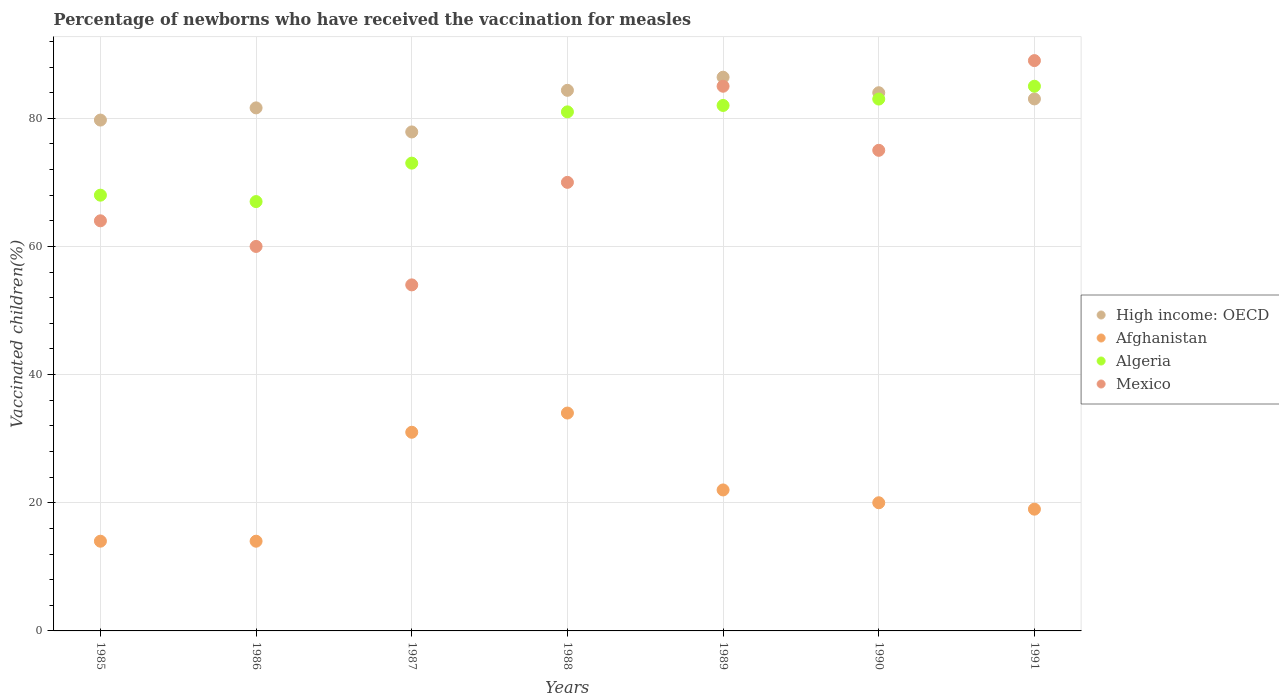How many different coloured dotlines are there?
Your response must be concise. 4. What is the percentage of vaccinated children in Afghanistan in 1986?
Provide a succinct answer. 14. Across all years, what is the maximum percentage of vaccinated children in Algeria?
Your answer should be compact. 85. Across all years, what is the minimum percentage of vaccinated children in Mexico?
Make the answer very short. 54. What is the total percentage of vaccinated children in Algeria in the graph?
Give a very brief answer. 539. What is the difference between the percentage of vaccinated children in Mexico in 1985 and the percentage of vaccinated children in High income: OECD in 1991?
Your answer should be compact. -19.02. What is the average percentage of vaccinated children in High income: OECD per year?
Keep it short and to the point. 82.43. In the year 1987, what is the difference between the percentage of vaccinated children in Algeria and percentage of vaccinated children in High income: OECD?
Provide a short and direct response. -4.87. What is the ratio of the percentage of vaccinated children in Algeria in 1986 to that in 1987?
Provide a short and direct response. 0.92. Is the difference between the percentage of vaccinated children in Algeria in 1985 and 1988 greater than the difference between the percentage of vaccinated children in High income: OECD in 1985 and 1988?
Offer a very short reply. No. What is the difference between the highest and the lowest percentage of vaccinated children in High income: OECD?
Make the answer very short. 8.54. Is the sum of the percentage of vaccinated children in Algeria in 1987 and 1990 greater than the maximum percentage of vaccinated children in Afghanistan across all years?
Your answer should be compact. Yes. Is it the case that in every year, the sum of the percentage of vaccinated children in Mexico and percentage of vaccinated children in Afghanistan  is greater than the sum of percentage of vaccinated children in Algeria and percentage of vaccinated children in High income: OECD?
Keep it short and to the point. No. Does the percentage of vaccinated children in Afghanistan monotonically increase over the years?
Give a very brief answer. No. Is the percentage of vaccinated children in Mexico strictly greater than the percentage of vaccinated children in Afghanistan over the years?
Your answer should be very brief. Yes. How many years are there in the graph?
Provide a succinct answer. 7. What is the difference between two consecutive major ticks on the Y-axis?
Give a very brief answer. 20. Are the values on the major ticks of Y-axis written in scientific E-notation?
Your response must be concise. No. Does the graph contain any zero values?
Ensure brevity in your answer.  No. Where does the legend appear in the graph?
Make the answer very short. Center right. What is the title of the graph?
Your response must be concise. Percentage of newborns who have received the vaccination for measles. What is the label or title of the X-axis?
Offer a very short reply. Years. What is the label or title of the Y-axis?
Make the answer very short. Vaccinated children(%). What is the Vaccinated children(%) in High income: OECD in 1985?
Offer a very short reply. 79.72. What is the Vaccinated children(%) in Algeria in 1985?
Give a very brief answer. 68. What is the Vaccinated children(%) in Mexico in 1985?
Your answer should be compact. 64. What is the Vaccinated children(%) of High income: OECD in 1986?
Provide a succinct answer. 81.62. What is the Vaccinated children(%) in Mexico in 1986?
Offer a terse response. 60. What is the Vaccinated children(%) of High income: OECD in 1987?
Offer a terse response. 77.87. What is the Vaccinated children(%) in High income: OECD in 1988?
Ensure brevity in your answer.  84.36. What is the Vaccinated children(%) of Afghanistan in 1988?
Your answer should be very brief. 34. What is the Vaccinated children(%) of High income: OECD in 1989?
Offer a very short reply. 86.41. What is the Vaccinated children(%) in High income: OECD in 1990?
Your response must be concise. 83.99. What is the Vaccinated children(%) of Algeria in 1990?
Provide a short and direct response. 83. What is the Vaccinated children(%) in Mexico in 1990?
Your answer should be compact. 75. What is the Vaccinated children(%) of High income: OECD in 1991?
Offer a very short reply. 83.02. What is the Vaccinated children(%) in Afghanistan in 1991?
Provide a succinct answer. 19. What is the Vaccinated children(%) in Algeria in 1991?
Provide a succinct answer. 85. What is the Vaccinated children(%) in Mexico in 1991?
Your answer should be very brief. 89. Across all years, what is the maximum Vaccinated children(%) in High income: OECD?
Make the answer very short. 86.41. Across all years, what is the maximum Vaccinated children(%) of Mexico?
Your answer should be very brief. 89. Across all years, what is the minimum Vaccinated children(%) in High income: OECD?
Give a very brief answer. 77.87. Across all years, what is the minimum Vaccinated children(%) in Afghanistan?
Your answer should be very brief. 14. What is the total Vaccinated children(%) in High income: OECD in the graph?
Make the answer very short. 576.99. What is the total Vaccinated children(%) of Afghanistan in the graph?
Give a very brief answer. 154. What is the total Vaccinated children(%) of Algeria in the graph?
Keep it short and to the point. 539. What is the total Vaccinated children(%) in Mexico in the graph?
Provide a succinct answer. 497. What is the difference between the Vaccinated children(%) of High income: OECD in 1985 and that in 1986?
Offer a very short reply. -1.9. What is the difference between the Vaccinated children(%) in Algeria in 1985 and that in 1986?
Offer a very short reply. 1. What is the difference between the Vaccinated children(%) in High income: OECD in 1985 and that in 1987?
Your response must be concise. 1.85. What is the difference between the Vaccinated children(%) in Mexico in 1985 and that in 1987?
Offer a very short reply. 10. What is the difference between the Vaccinated children(%) of High income: OECD in 1985 and that in 1988?
Your response must be concise. -4.64. What is the difference between the Vaccinated children(%) of Afghanistan in 1985 and that in 1988?
Your answer should be compact. -20. What is the difference between the Vaccinated children(%) in Algeria in 1985 and that in 1988?
Your answer should be very brief. -13. What is the difference between the Vaccinated children(%) of High income: OECD in 1985 and that in 1989?
Your answer should be compact. -6.69. What is the difference between the Vaccinated children(%) in Afghanistan in 1985 and that in 1989?
Your response must be concise. -8. What is the difference between the Vaccinated children(%) of Algeria in 1985 and that in 1989?
Your response must be concise. -14. What is the difference between the Vaccinated children(%) in Mexico in 1985 and that in 1989?
Your answer should be compact. -21. What is the difference between the Vaccinated children(%) of High income: OECD in 1985 and that in 1990?
Offer a terse response. -4.27. What is the difference between the Vaccinated children(%) in Afghanistan in 1985 and that in 1990?
Keep it short and to the point. -6. What is the difference between the Vaccinated children(%) of Algeria in 1985 and that in 1990?
Your answer should be very brief. -15. What is the difference between the Vaccinated children(%) of High income: OECD in 1985 and that in 1991?
Offer a terse response. -3.3. What is the difference between the Vaccinated children(%) of Afghanistan in 1985 and that in 1991?
Your answer should be compact. -5. What is the difference between the Vaccinated children(%) in High income: OECD in 1986 and that in 1987?
Ensure brevity in your answer.  3.75. What is the difference between the Vaccinated children(%) of Afghanistan in 1986 and that in 1987?
Provide a succinct answer. -17. What is the difference between the Vaccinated children(%) in Algeria in 1986 and that in 1987?
Your answer should be very brief. -6. What is the difference between the Vaccinated children(%) in Mexico in 1986 and that in 1987?
Provide a succinct answer. 6. What is the difference between the Vaccinated children(%) of High income: OECD in 1986 and that in 1988?
Ensure brevity in your answer.  -2.74. What is the difference between the Vaccinated children(%) in Afghanistan in 1986 and that in 1988?
Offer a terse response. -20. What is the difference between the Vaccinated children(%) of Mexico in 1986 and that in 1988?
Give a very brief answer. -10. What is the difference between the Vaccinated children(%) of High income: OECD in 1986 and that in 1989?
Keep it short and to the point. -4.79. What is the difference between the Vaccinated children(%) in Algeria in 1986 and that in 1989?
Keep it short and to the point. -15. What is the difference between the Vaccinated children(%) in High income: OECD in 1986 and that in 1990?
Offer a terse response. -2.36. What is the difference between the Vaccinated children(%) of Algeria in 1986 and that in 1990?
Ensure brevity in your answer.  -16. What is the difference between the Vaccinated children(%) in High income: OECD in 1986 and that in 1991?
Offer a terse response. -1.4. What is the difference between the Vaccinated children(%) of Algeria in 1986 and that in 1991?
Provide a short and direct response. -18. What is the difference between the Vaccinated children(%) of High income: OECD in 1987 and that in 1988?
Offer a terse response. -6.49. What is the difference between the Vaccinated children(%) in Mexico in 1987 and that in 1988?
Give a very brief answer. -16. What is the difference between the Vaccinated children(%) in High income: OECD in 1987 and that in 1989?
Offer a very short reply. -8.54. What is the difference between the Vaccinated children(%) of Afghanistan in 1987 and that in 1989?
Your response must be concise. 9. What is the difference between the Vaccinated children(%) in Algeria in 1987 and that in 1989?
Provide a succinct answer. -9. What is the difference between the Vaccinated children(%) of Mexico in 1987 and that in 1989?
Your response must be concise. -31. What is the difference between the Vaccinated children(%) of High income: OECD in 1987 and that in 1990?
Keep it short and to the point. -6.12. What is the difference between the Vaccinated children(%) of Algeria in 1987 and that in 1990?
Make the answer very short. -10. What is the difference between the Vaccinated children(%) of Mexico in 1987 and that in 1990?
Offer a terse response. -21. What is the difference between the Vaccinated children(%) of High income: OECD in 1987 and that in 1991?
Your response must be concise. -5.15. What is the difference between the Vaccinated children(%) of Afghanistan in 1987 and that in 1991?
Offer a very short reply. 12. What is the difference between the Vaccinated children(%) of Mexico in 1987 and that in 1991?
Your answer should be very brief. -35. What is the difference between the Vaccinated children(%) of High income: OECD in 1988 and that in 1989?
Ensure brevity in your answer.  -2.04. What is the difference between the Vaccinated children(%) of Afghanistan in 1988 and that in 1989?
Provide a short and direct response. 12. What is the difference between the Vaccinated children(%) of High income: OECD in 1988 and that in 1990?
Provide a short and direct response. 0.38. What is the difference between the Vaccinated children(%) of Algeria in 1988 and that in 1990?
Keep it short and to the point. -2. What is the difference between the Vaccinated children(%) of High income: OECD in 1988 and that in 1991?
Offer a very short reply. 1.34. What is the difference between the Vaccinated children(%) in Mexico in 1988 and that in 1991?
Offer a very short reply. -19. What is the difference between the Vaccinated children(%) in High income: OECD in 1989 and that in 1990?
Make the answer very short. 2.42. What is the difference between the Vaccinated children(%) of Algeria in 1989 and that in 1990?
Offer a terse response. -1. What is the difference between the Vaccinated children(%) of High income: OECD in 1989 and that in 1991?
Your answer should be compact. 3.39. What is the difference between the Vaccinated children(%) of Afghanistan in 1989 and that in 1991?
Ensure brevity in your answer.  3. What is the difference between the Vaccinated children(%) in Algeria in 1989 and that in 1991?
Offer a very short reply. -3. What is the difference between the Vaccinated children(%) of Mexico in 1989 and that in 1991?
Ensure brevity in your answer.  -4. What is the difference between the Vaccinated children(%) of High income: OECD in 1990 and that in 1991?
Your answer should be compact. 0.97. What is the difference between the Vaccinated children(%) of Algeria in 1990 and that in 1991?
Your answer should be very brief. -2. What is the difference between the Vaccinated children(%) in Mexico in 1990 and that in 1991?
Keep it short and to the point. -14. What is the difference between the Vaccinated children(%) in High income: OECD in 1985 and the Vaccinated children(%) in Afghanistan in 1986?
Your response must be concise. 65.72. What is the difference between the Vaccinated children(%) of High income: OECD in 1985 and the Vaccinated children(%) of Algeria in 1986?
Offer a very short reply. 12.72. What is the difference between the Vaccinated children(%) in High income: OECD in 1985 and the Vaccinated children(%) in Mexico in 1986?
Provide a succinct answer. 19.72. What is the difference between the Vaccinated children(%) of Afghanistan in 1985 and the Vaccinated children(%) of Algeria in 1986?
Keep it short and to the point. -53. What is the difference between the Vaccinated children(%) of Afghanistan in 1985 and the Vaccinated children(%) of Mexico in 1986?
Give a very brief answer. -46. What is the difference between the Vaccinated children(%) of Algeria in 1985 and the Vaccinated children(%) of Mexico in 1986?
Ensure brevity in your answer.  8. What is the difference between the Vaccinated children(%) of High income: OECD in 1985 and the Vaccinated children(%) of Afghanistan in 1987?
Your answer should be compact. 48.72. What is the difference between the Vaccinated children(%) of High income: OECD in 1985 and the Vaccinated children(%) of Algeria in 1987?
Provide a short and direct response. 6.72. What is the difference between the Vaccinated children(%) of High income: OECD in 1985 and the Vaccinated children(%) of Mexico in 1987?
Offer a very short reply. 25.72. What is the difference between the Vaccinated children(%) of Afghanistan in 1985 and the Vaccinated children(%) of Algeria in 1987?
Offer a very short reply. -59. What is the difference between the Vaccinated children(%) in Algeria in 1985 and the Vaccinated children(%) in Mexico in 1987?
Provide a short and direct response. 14. What is the difference between the Vaccinated children(%) in High income: OECD in 1985 and the Vaccinated children(%) in Afghanistan in 1988?
Your response must be concise. 45.72. What is the difference between the Vaccinated children(%) in High income: OECD in 1985 and the Vaccinated children(%) in Algeria in 1988?
Ensure brevity in your answer.  -1.28. What is the difference between the Vaccinated children(%) in High income: OECD in 1985 and the Vaccinated children(%) in Mexico in 1988?
Your response must be concise. 9.72. What is the difference between the Vaccinated children(%) of Afghanistan in 1985 and the Vaccinated children(%) of Algeria in 1988?
Your response must be concise. -67. What is the difference between the Vaccinated children(%) in Afghanistan in 1985 and the Vaccinated children(%) in Mexico in 1988?
Your answer should be very brief. -56. What is the difference between the Vaccinated children(%) in Algeria in 1985 and the Vaccinated children(%) in Mexico in 1988?
Your answer should be very brief. -2. What is the difference between the Vaccinated children(%) in High income: OECD in 1985 and the Vaccinated children(%) in Afghanistan in 1989?
Provide a succinct answer. 57.72. What is the difference between the Vaccinated children(%) of High income: OECD in 1985 and the Vaccinated children(%) of Algeria in 1989?
Offer a terse response. -2.28. What is the difference between the Vaccinated children(%) in High income: OECD in 1985 and the Vaccinated children(%) in Mexico in 1989?
Offer a very short reply. -5.28. What is the difference between the Vaccinated children(%) in Afghanistan in 1985 and the Vaccinated children(%) in Algeria in 1989?
Your response must be concise. -68. What is the difference between the Vaccinated children(%) of Afghanistan in 1985 and the Vaccinated children(%) of Mexico in 1989?
Keep it short and to the point. -71. What is the difference between the Vaccinated children(%) of High income: OECD in 1985 and the Vaccinated children(%) of Afghanistan in 1990?
Your answer should be compact. 59.72. What is the difference between the Vaccinated children(%) in High income: OECD in 1985 and the Vaccinated children(%) in Algeria in 1990?
Offer a terse response. -3.28. What is the difference between the Vaccinated children(%) in High income: OECD in 1985 and the Vaccinated children(%) in Mexico in 1990?
Keep it short and to the point. 4.72. What is the difference between the Vaccinated children(%) of Afghanistan in 1985 and the Vaccinated children(%) of Algeria in 1990?
Ensure brevity in your answer.  -69. What is the difference between the Vaccinated children(%) in Afghanistan in 1985 and the Vaccinated children(%) in Mexico in 1990?
Offer a very short reply. -61. What is the difference between the Vaccinated children(%) in High income: OECD in 1985 and the Vaccinated children(%) in Afghanistan in 1991?
Ensure brevity in your answer.  60.72. What is the difference between the Vaccinated children(%) in High income: OECD in 1985 and the Vaccinated children(%) in Algeria in 1991?
Keep it short and to the point. -5.28. What is the difference between the Vaccinated children(%) of High income: OECD in 1985 and the Vaccinated children(%) of Mexico in 1991?
Provide a short and direct response. -9.28. What is the difference between the Vaccinated children(%) in Afghanistan in 1985 and the Vaccinated children(%) in Algeria in 1991?
Make the answer very short. -71. What is the difference between the Vaccinated children(%) of Afghanistan in 1985 and the Vaccinated children(%) of Mexico in 1991?
Provide a succinct answer. -75. What is the difference between the Vaccinated children(%) in High income: OECD in 1986 and the Vaccinated children(%) in Afghanistan in 1987?
Offer a very short reply. 50.62. What is the difference between the Vaccinated children(%) of High income: OECD in 1986 and the Vaccinated children(%) of Algeria in 1987?
Provide a succinct answer. 8.62. What is the difference between the Vaccinated children(%) in High income: OECD in 1986 and the Vaccinated children(%) in Mexico in 1987?
Offer a very short reply. 27.62. What is the difference between the Vaccinated children(%) in Afghanistan in 1986 and the Vaccinated children(%) in Algeria in 1987?
Give a very brief answer. -59. What is the difference between the Vaccinated children(%) of High income: OECD in 1986 and the Vaccinated children(%) of Afghanistan in 1988?
Your answer should be compact. 47.62. What is the difference between the Vaccinated children(%) in High income: OECD in 1986 and the Vaccinated children(%) in Algeria in 1988?
Provide a short and direct response. 0.62. What is the difference between the Vaccinated children(%) in High income: OECD in 1986 and the Vaccinated children(%) in Mexico in 1988?
Keep it short and to the point. 11.62. What is the difference between the Vaccinated children(%) of Afghanistan in 1986 and the Vaccinated children(%) of Algeria in 1988?
Give a very brief answer. -67. What is the difference between the Vaccinated children(%) in Afghanistan in 1986 and the Vaccinated children(%) in Mexico in 1988?
Your response must be concise. -56. What is the difference between the Vaccinated children(%) in High income: OECD in 1986 and the Vaccinated children(%) in Afghanistan in 1989?
Provide a succinct answer. 59.62. What is the difference between the Vaccinated children(%) in High income: OECD in 1986 and the Vaccinated children(%) in Algeria in 1989?
Your response must be concise. -0.38. What is the difference between the Vaccinated children(%) of High income: OECD in 1986 and the Vaccinated children(%) of Mexico in 1989?
Your answer should be compact. -3.38. What is the difference between the Vaccinated children(%) of Afghanistan in 1986 and the Vaccinated children(%) of Algeria in 1989?
Give a very brief answer. -68. What is the difference between the Vaccinated children(%) of Afghanistan in 1986 and the Vaccinated children(%) of Mexico in 1989?
Keep it short and to the point. -71. What is the difference between the Vaccinated children(%) in Algeria in 1986 and the Vaccinated children(%) in Mexico in 1989?
Keep it short and to the point. -18. What is the difference between the Vaccinated children(%) of High income: OECD in 1986 and the Vaccinated children(%) of Afghanistan in 1990?
Ensure brevity in your answer.  61.62. What is the difference between the Vaccinated children(%) of High income: OECD in 1986 and the Vaccinated children(%) of Algeria in 1990?
Your answer should be compact. -1.38. What is the difference between the Vaccinated children(%) in High income: OECD in 1986 and the Vaccinated children(%) in Mexico in 1990?
Your response must be concise. 6.62. What is the difference between the Vaccinated children(%) in Afghanistan in 1986 and the Vaccinated children(%) in Algeria in 1990?
Offer a very short reply. -69. What is the difference between the Vaccinated children(%) in Afghanistan in 1986 and the Vaccinated children(%) in Mexico in 1990?
Ensure brevity in your answer.  -61. What is the difference between the Vaccinated children(%) of Algeria in 1986 and the Vaccinated children(%) of Mexico in 1990?
Offer a very short reply. -8. What is the difference between the Vaccinated children(%) of High income: OECD in 1986 and the Vaccinated children(%) of Afghanistan in 1991?
Provide a succinct answer. 62.62. What is the difference between the Vaccinated children(%) in High income: OECD in 1986 and the Vaccinated children(%) in Algeria in 1991?
Ensure brevity in your answer.  -3.38. What is the difference between the Vaccinated children(%) of High income: OECD in 1986 and the Vaccinated children(%) of Mexico in 1991?
Keep it short and to the point. -7.38. What is the difference between the Vaccinated children(%) in Afghanistan in 1986 and the Vaccinated children(%) in Algeria in 1991?
Ensure brevity in your answer.  -71. What is the difference between the Vaccinated children(%) in Afghanistan in 1986 and the Vaccinated children(%) in Mexico in 1991?
Provide a succinct answer. -75. What is the difference between the Vaccinated children(%) in High income: OECD in 1987 and the Vaccinated children(%) in Afghanistan in 1988?
Offer a very short reply. 43.87. What is the difference between the Vaccinated children(%) in High income: OECD in 1987 and the Vaccinated children(%) in Algeria in 1988?
Provide a succinct answer. -3.13. What is the difference between the Vaccinated children(%) of High income: OECD in 1987 and the Vaccinated children(%) of Mexico in 1988?
Your answer should be very brief. 7.87. What is the difference between the Vaccinated children(%) in Afghanistan in 1987 and the Vaccinated children(%) in Algeria in 1988?
Your answer should be compact. -50. What is the difference between the Vaccinated children(%) in Afghanistan in 1987 and the Vaccinated children(%) in Mexico in 1988?
Provide a succinct answer. -39. What is the difference between the Vaccinated children(%) in High income: OECD in 1987 and the Vaccinated children(%) in Afghanistan in 1989?
Keep it short and to the point. 55.87. What is the difference between the Vaccinated children(%) in High income: OECD in 1987 and the Vaccinated children(%) in Algeria in 1989?
Keep it short and to the point. -4.13. What is the difference between the Vaccinated children(%) in High income: OECD in 1987 and the Vaccinated children(%) in Mexico in 1989?
Your answer should be very brief. -7.13. What is the difference between the Vaccinated children(%) of Afghanistan in 1987 and the Vaccinated children(%) of Algeria in 1989?
Your answer should be very brief. -51. What is the difference between the Vaccinated children(%) of Afghanistan in 1987 and the Vaccinated children(%) of Mexico in 1989?
Keep it short and to the point. -54. What is the difference between the Vaccinated children(%) of High income: OECD in 1987 and the Vaccinated children(%) of Afghanistan in 1990?
Keep it short and to the point. 57.87. What is the difference between the Vaccinated children(%) in High income: OECD in 1987 and the Vaccinated children(%) in Algeria in 1990?
Make the answer very short. -5.13. What is the difference between the Vaccinated children(%) of High income: OECD in 1987 and the Vaccinated children(%) of Mexico in 1990?
Offer a terse response. 2.87. What is the difference between the Vaccinated children(%) of Afghanistan in 1987 and the Vaccinated children(%) of Algeria in 1990?
Your answer should be very brief. -52. What is the difference between the Vaccinated children(%) of Afghanistan in 1987 and the Vaccinated children(%) of Mexico in 1990?
Ensure brevity in your answer.  -44. What is the difference between the Vaccinated children(%) of High income: OECD in 1987 and the Vaccinated children(%) of Afghanistan in 1991?
Ensure brevity in your answer.  58.87. What is the difference between the Vaccinated children(%) in High income: OECD in 1987 and the Vaccinated children(%) in Algeria in 1991?
Your response must be concise. -7.13. What is the difference between the Vaccinated children(%) of High income: OECD in 1987 and the Vaccinated children(%) of Mexico in 1991?
Give a very brief answer. -11.13. What is the difference between the Vaccinated children(%) of Afghanistan in 1987 and the Vaccinated children(%) of Algeria in 1991?
Your answer should be compact. -54. What is the difference between the Vaccinated children(%) in Afghanistan in 1987 and the Vaccinated children(%) in Mexico in 1991?
Give a very brief answer. -58. What is the difference between the Vaccinated children(%) in Algeria in 1987 and the Vaccinated children(%) in Mexico in 1991?
Ensure brevity in your answer.  -16. What is the difference between the Vaccinated children(%) in High income: OECD in 1988 and the Vaccinated children(%) in Afghanistan in 1989?
Make the answer very short. 62.36. What is the difference between the Vaccinated children(%) in High income: OECD in 1988 and the Vaccinated children(%) in Algeria in 1989?
Ensure brevity in your answer.  2.36. What is the difference between the Vaccinated children(%) of High income: OECD in 1988 and the Vaccinated children(%) of Mexico in 1989?
Keep it short and to the point. -0.64. What is the difference between the Vaccinated children(%) of Afghanistan in 1988 and the Vaccinated children(%) of Algeria in 1989?
Give a very brief answer. -48. What is the difference between the Vaccinated children(%) of Afghanistan in 1988 and the Vaccinated children(%) of Mexico in 1989?
Offer a terse response. -51. What is the difference between the Vaccinated children(%) of High income: OECD in 1988 and the Vaccinated children(%) of Afghanistan in 1990?
Give a very brief answer. 64.36. What is the difference between the Vaccinated children(%) in High income: OECD in 1988 and the Vaccinated children(%) in Algeria in 1990?
Make the answer very short. 1.36. What is the difference between the Vaccinated children(%) of High income: OECD in 1988 and the Vaccinated children(%) of Mexico in 1990?
Offer a very short reply. 9.36. What is the difference between the Vaccinated children(%) in Afghanistan in 1988 and the Vaccinated children(%) in Algeria in 1990?
Your answer should be very brief. -49. What is the difference between the Vaccinated children(%) in Afghanistan in 1988 and the Vaccinated children(%) in Mexico in 1990?
Make the answer very short. -41. What is the difference between the Vaccinated children(%) in Algeria in 1988 and the Vaccinated children(%) in Mexico in 1990?
Your response must be concise. 6. What is the difference between the Vaccinated children(%) in High income: OECD in 1988 and the Vaccinated children(%) in Afghanistan in 1991?
Your response must be concise. 65.36. What is the difference between the Vaccinated children(%) of High income: OECD in 1988 and the Vaccinated children(%) of Algeria in 1991?
Provide a short and direct response. -0.64. What is the difference between the Vaccinated children(%) of High income: OECD in 1988 and the Vaccinated children(%) of Mexico in 1991?
Your answer should be very brief. -4.64. What is the difference between the Vaccinated children(%) of Afghanistan in 1988 and the Vaccinated children(%) of Algeria in 1991?
Your answer should be very brief. -51. What is the difference between the Vaccinated children(%) in Afghanistan in 1988 and the Vaccinated children(%) in Mexico in 1991?
Make the answer very short. -55. What is the difference between the Vaccinated children(%) in Algeria in 1988 and the Vaccinated children(%) in Mexico in 1991?
Your answer should be compact. -8. What is the difference between the Vaccinated children(%) of High income: OECD in 1989 and the Vaccinated children(%) of Afghanistan in 1990?
Your answer should be compact. 66.41. What is the difference between the Vaccinated children(%) in High income: OECD in 1989 and the Vaccinated children(%) in Algeria in 1990?
Keep it short and to the point. 3.41. What is the difference between the Vaccinated children(%) of High income: OECD in 1989 and the Vaccinated children(%) of Mexico in 1990?
Offer a terse response. 11.41. What is the difference between the Vaccinated children(%) in Afghanistan in 1989 and the Vaccinated children(%) in Algeria in 1990?
Offer a very short reply. -61. What is the difference between the Vaccinated children(%) of Afghanistan in 1989 and the Vaccinated children(%) of Mexico in 1990?
Offer a very short reply. -53. What is the difference between the Vaccinated children(%) in Algeria in 1989 and the Vaccinated children(%) in Mexico in 1990?
Your answer should be very brief. 7. What is the difference between the Vaccinated children(%) in High income: OECD in 1989 and the Vaccinated children(%) in Afghanistan in 1991?
Ensure brevity in your answer.  67.41. What is the difference between the Vaccinated children(%) of High income: OECD in 1989 and the Vaccinated children(%) of Algeria in 1991?
Offer a terse response. 1.41. What is the difference between the Vaccinated children(%) of High income: OECD in 1989 and the Vaccinated children(%) of Mexico in 1991?
Your response must be concise. -2.59. What is the difference between the Vaccinated children(%) of Afghanistan in 1989 and the Vaccinated children(%) of Algeria in 1991?
Offer a terse response. -63. What is the difference between the Vaccinated children(%) of Afghanistan in 1989 and the Vaccinated children(%) of Mexico in 1991?
Offer a terse response. -67. What is the difference between the Vaccinated children(%) in Algeria in 1989 and the Vaccinated children(%) in Mexico in 1991?
Your response must be concise. -7. What is the difference between the Vaccinated children(%) of High income: OECD in 1990 and the Vaccinated children(%) of Afghanistan in 1991?
Offer a terse response. 64.99. What is the difference between the Vaccinated children(%) of High income: OECD in 1990 and the Vaccinated children(%) of Algeria in 1991?
Your answer should be compact. -1.01. What is the difference between the Vaccinated children(%) in High income: OECD in 1990 and the Vaccinated children(%) in Mexico in 1991?
Provide a succinct answer. -5.01. What is the difference between the Vaccinated children(%) in Afghanistan in 1990 and the Vaccinated children(%) in Algeria in 1991?
Provide a succinct answer. -65. What is the difference between the Vaccinated children(%) of Afghanistan in 1990 and the Vaccinated children(%) of Mexico in 1991?
Your answer should be very brief. -69. What is the average Vaccinated children(%) of High income: OECD per year?
Make the answer very short. 82.43. What is the average Vaccinated children(%) of Afghanistan per year?
Your answer should be very brief. 22. What is the average Vaccinated children(%) in Algeria per year?
Offer a terse response. 77. In the year 1985, what is the difference between the Vaccinated children(%) in High income: OECD and Vaccinated children(%) in Afghanistan?
Your answer should be compact. 65.72. In the year 1985, what is the difference between the Vaccinated children(%) of High income: OECD and Vaccinated children(%) of Algeria?
Offer a terse response. 11.72. In the year 1985, what is the difference between the Vaccinated children(%) in High income: OECD and Vaccinated children(%) in Mexico?
Your answer should be compact. 15.72. In the year 1985, what is the difference between the Vaccinated children(%) of Afghanistan and Vaccinated children(%) of Algeria?
Your response must be concise. -54. In the year 1985, what is the difference between the Vaccinated children(%) in Afghanistan and Vaccinated children(%) in Mexico?
Offer a terse response. -50. In the year 1985, what is the difference between the Vaccinated children(%) in Algeria and Vaccinated children(%) in Mexico?
Provide a succinct answer. 4. In the year 1986, what is the difference between the Vaccinated children(%) in High income: OECD and Vaccinated children(%) in Afghanistan?
Provide a succinct answer. 67.62. In the year 1986, what is the difference between the Vaccinated children(%) in High income: OECD and Vaccinated children(%) in Algeria?
Make the answer very short. 14.62. In the year 1986, what is the difference between the Vaccinated children(%) in High income: OECD and Vaccinated children(%) in Mexico?
Your answer should be compact. 21.62. In the year 1986, what is the difference between the Vaccinated children(%) in Afghanistan and Vaccinated children(%) in Algeria?
Your answer should be compact. -53. In the year 1986, what is the difference between the Vaccinated children(%) in Afghanistan and Vaccinated children(%) in Mexico?
Your answer should be very brief. -46. In the year 1987, what is the difference between the Vaccinated children(%) of High income: OECD and Vaccinated children(%) of Afghanistan?
Keep it short and to the point. 46.87. In the year 1987, what is the difference between the Vaccinated children(%) of High income: OECD and Vaccinated children(%) of Algeria?
Your response must be concise. 4.87. In the year 1987, what is the difference between the Vaccinated children(%) in High income: OECD and Vaccinated children(%) in Mexico?
Your response must be concise. 23.87. In the year 1987, what is the difference between the Vaccinated children(%) of Afghanistan and Vaccinated children(%) of Algeria?
Keep it short and to the point. -42. In the year 1988, what is the difference between the Vaccinated children(%) of High income: OECD and Vaccinated children(%) of Afghanistan?
Your answer should be compact. 50.36. In the year 1988, what is the difference between the Vaccinated children(%) of High income: OECD and Vaccinated children(%) of Algeria?
Offer a very short reply. 3.36. In the year 1988, what is the difference between the Vaccinated children(%) in High income: OECD and Vaccinated children(%) in Mexico?
Keep it short and to the point. 14.36. In the year 1988, what is the difference between the Vaccinated children(%) in Afghanistan and Vaccinated children(%) in Algeria?
Provide a succinct answer. -47. In the year 1988, what is the difference between the Vaccinated children(%) of Afghanistan and Vaccinated children(%) of Mexico?
Provide a succinct answer. -36. In the year 1988, what is the difference between the Vaccinated children(%) of Algeria and Vaccinated children(%) of Mexico?
Provide a succinct answer. 11. In the year 1989, what is the difference between the Vaccinated children(%) of High income: OECD and Vaccinated children(%) of Afghanistan?
Give a very brief answer. 64.41. In the year 1989, what is the difference between the Vaccinated children(%) of High income: OECD and Vaccinated children(%) of Algeria?
Offer a very short reply. 4.41. In the year 1989, what is the difference between the Vaccinated children(%) in High income: OECD and Vaccinated children(%) in Mexico?
Make the answer very short. 1.41. In the year 1989, what is the difference between the Vaccinated children(%) in Afghanistan and Vaccinated children(%) in Algeria?
Offer a terse response. -60. In the year 1989, what is the difference between the Vaccinated children(%) of Afghanistan and Vaccinated children(%) of Mexico?
Give a very brief answer. -63. In the year 1990, what is the difference between the Vaccinated children(%) in High income: OECD and Vaccinated children(%) in Afghanistan?
Give a very brief answer. 63.99. In the year 1990, what is the difference between the Vaccinated children(%) of High income: OECD and Vaccinated children(%) of Algeria?
Offer a very short reply. 0.99. In the year 1990, what is the difference between the Vaccinated children(%) of High income: OECD and Vaccinated children(%) of Mexico?
Your answer should be very brief. 8.99. In the year 1990, what is the difference between the Vaccinated children(%) in Afghanistan and Vaccinated children(%) in Algeria?
Your answer should be compact. -63. In the year 1990, what is the difference between the Vaccinated children(%) of Afghanistan and Vaccinated children(%) of Mexico?
Make the answer very short. -55. In the year 1990, what is the difference between the Vaccinated children(%) of Algeria and Vaccinated children(%) of Mexico?
Keep it short and to the point. 8. In the year 1991, what is the difference between the Vaccinated children(%) in High income: OECD and Vaccinated children(%) in Afghanistan?
Your answer should be compact. 64.02. In the year 1991, what is the difference between the Vaccinated children(%) in High income: OECD and Vaccinated children(%) in Algeria?
Your response must be concise. -1.98. In the year 1991, what is the difference between the Vaccinated children(%) of High income: OECD and Vaccinated children(%) of Mexico?
Provide a short and direct response. -5.98. In the year 1991, what is the difference between the Vaccinated children(%) in Afghanistan and Vaccinated children(%) in Algeria?
Your answer should be compact. -66. In the year 1991, what is the difference between the Vaccinated children(%) in Afghanistan and Vaccinated children(%) in Mexico?
Ensure brevity in your answer.  -70. What is the ratio of the Vaccinated children(%) in High income: OECD in 1985 to that in 1986?
Make the answer very short. 0.98. What is the ratio of the Vaccinated children(%) in Afghanistan in 1985 to that in 1986?
Offer a terse response. 1. What is the ratio of the Vaccinated children(%) of Algeria in 1985 to that in 1986?
Provide a short and direct response. 1.01. What is the ratio of the Vaccinated children(%) of Mexico in 1985 to that in 1986?
Your response must be concise. 1.07. What is the ratio of the Vaccinated children(%) of High income: OECD in 1985 to that in 1987?
Provide a succinct answer. 1.02. What is the ratio of the Vaccinated children(%) in Afghanistan in 1985 to that in 1987?
Offer a very short reply. 0.45. What is the ratio of the Vaccinated children(%) of Algeria in 1985 to that in 1987?
Ensure brevity in your answer.  0.93. What is the ratio of the Vaccinated children(%) in Mexico in 1985 to that in 1987?
Make the answer very short. 1.19. What is the ratio of the Vaccinated children(%) of High income: OECD in 1985 to that in 1988?
Your response must be concise. 0.94. What is the ratio of the Vaccinated children(%) in Afghanistan in 1985 to that in 1988?
Give a very brief answer. 0.41. What is the ratio of the Vaccinated children(%) in Algeria in 1985 to that in 1988?
Your answer should be very brief. 0.84. What is the ratio of the Vaccinated children(%) of Mexico in 1985 to that in 1988?
Your answer should be very brief. 0.91. What is the ratio of the Vaccinated children(%) of High income: OECD in 1985 to that in 1989?
Offer a terse response. 0.92. What is the ratio of the Vaccinated children(%) in Afghanistan in 1985 to that in 1989?
Offer a very short reply. 0.64. What is the ratio of the Vaccinated children(%) of Algeria in 1985 to that in 1989?
Your answer should be compact. 0.83. What is the ratio of the Vaccinated children(%) of Mexico in 1985 to that in 1989?
Give a very brief answer. 0.75. What is the ratio of the Vaccinated children(%) of High income: OECD in 1985 to that in 1990?
Make the answer very short. 0.95. What is the ratio of the Vaccinated children(%) of Algeria in 1985 to that in 1990?
Make the answer very short. 0.82. What is the ratio of the Vaccinated children(%) of Mexico in 1985 to that in 1990?
Provide a short and direct response. 0.85. What is the ratio of the Vaccinated children(%) of High income: OECD in 1985 to that in 1991?
Your answer should be very brief. 0.96. What is the ratio of the Vaccinated children(%) in Afghanistan in 1985 to that in 1991?
Your answer should be very brief. 0.74. What is the ratio of the Vaccinated children(%) in Algeria in 1985 to that in 1991?
Ensure brevity in your answer.  0.8. What is the ratio of the Vaccinated children(%) in Mexico in 1985 to that in 1991?
Your answer should be very brief. 0.72. What is the ratio of the Vaccinated children(%) of High income: OECD in 1986 to that in 1987?
Your answer should be compact. 1.05. What is the ratio of the Vaccinated children(%) in Afghanistan in 1986 to that in 1987?
Give a very brief answer. 0.45. What is the ratio of the Vaccinated children(%) of Algeria in 1986 to that in 1987?
Offer a very short reply. 0.92. What is the ratio of the Vaccinated children(%) of High income: OECD in 1986 to that in 1988?
Give a very brief answer. 0.97. What is the ratio of the Vaccinated children(%) of Afghanistan in 1986 to that in 1988?
Offer a terse response. 0.41. What is the ratio of the Vaccinated children(%) of Algeria in 1986 to that in 1988?
Offer a terse response. 0.83. What is the ratio of the Vaccinated children(%) of High income: OECD in 1986 to that in 1989?
Give a very brief answer. 0.94. What is the ratio of the Vaccinated children(%) of Afghanistan in 1986 to that in 1989?
Give a very brief answer. 0.64. What is the ratio of the Vaccinated children(%) in Algeria in 1986 to that in 1989?
Your answer should be very brief. 0.82. What is the ratio of the Vaccinated children(%) in Mexico in 1986 to that in 1989?
Provide a short and direct response. 0.71. What is the ratio of the Vaccinated children(%) of High income: OECD in 1986 to that in 1990?
Offer a terse response. 0.97. What is the ratio of the Vaccinated children(%) of Afghanistan in 1986 to that in 1990?
Keep it short and to the point. 0.7. What is the ratio of the Vaccinated children(%) of Algeria in 1986 to that in 1990?
Provide a succinct answer. 0.81. What is the ratio of the Vaccinated children(%) of High income: OECD in 1986 to that in 1991?
Your answer should be very brief. 0.98. What is the ratio of the Vaccinated children(%) of Afghanistan in 1986 to that in 1991?
Ensure brevity in your answer.  0.74. What is the ratio of the Vaccinated children(%) in Algeria in 1986 to that in 1991?
Your answer should be very brief. 0.79. What is the ratio of the Vaccinated children(%) of Mexico in 1986 to that in 1991?
Your answer should be very brief. 0.67. What is the ratio of the Vaccinated children(%) of High income: OECD in 1987 to that in 1988?
Keep it short and to the point. 0.92. What is the ratio of the Vaccinated children(%) of Afghanistan in 1987 to that in 1988?
Offer a very short reply. 0.91. What is the ratio of the Vaccinated children(%) in Algeria in 1987 to that in 1988?
Offer a very short reply. 0.9. What is the ratio of the Vaccinated children(%) in Mexico in 1987 to that in 1988?
Your response must be concise. 0.77. What is the ratio of the Vaccinated children(%) of High income: OECD in 1987 to that in 1989?
Your response must be concise. 0.9. What is the ratio of the Vaccinated children(%) in Afghanistan in 1987 to that in 1989?
Offer a very short reply. 1.41. What is the ratio of the Vaccinated children(%) of Algeria in 1987 to that in 1989?
Your answer should be very brief. 0.89. What is the ratio of the Vaccinated children(%) of Mexico in 1987 to that in 1989?
Your response must be concise. 0.64. What is the ratio of the Vaccinated children(%) in High income: OECD in 1987 to that in 1990?
Your answer should be very brief. 0.93. What is the ratio of the Vaccinated children(%) in Afghanistan in 1987 to that in 1990?
Ensure brevity in your answer.  1.55. What is the ratio of the Vaccinated children(%) of Algeria in 1987 to that in 1990?
Your answer should be compact. 0.88. What is the ratio of the Vaccinated children(%) of Mexico in 1987 to that in 1990?
Keep it short and to the point. 0.72. What is the ratio of the Vaccinated children(%) of High income: OECD in 1987 to that in 1991?
Offer a terse response. 0.94. What is the ratio of the Vaccinated children(%) of Afghanistan in 1987 to that in 1991?
Your answer should be very brief. 1.63. What is the ratio of the Vaccinated children(%) of Algeria in 1987 to that in 1991?
Provide a short and direct response. 0.86. What is the ratio of the Vaccinated children(%) in Mexico in 1987 to that in 1991?
Offer a terse response. 0.61. What is the ratio of the Vaccinated children(%) in High income: OECD in 1988 to that in 1989?
Your response must be concise. 0.98. What is the ratio of the Vaccinated children(%) in Afghanistan in 1988 to that in 1989?
Provide a succinct answer. 1.55. What is the ratio of the Vaccinated children(%) of Algeria in 1988 to that in 1989?
Offer a terse response. 0.99. What is the ratio of the Vaccinated children(%) in Mexico in 1988 to that in 1989?
Your answer should be very brief. 0.82. What is the ratio of the Vaccinated children(%) of High income: OECD in 1988 to that in 1990?
Give a very brief answer. 1. What is the ratio of the Vaccinated children(%) of Algeria in 1988 to that in 1990?
Your answer should be very brief. 0.98. What is the ratio of the Vaccinated children(%) of High income: OECD in 1988 to that in 1991?
Ensure brevity in your answer.  1.02. What is the ratio of the Vaccinated children(%) of Afghanistan in 1988 to that in 1991?
Ensure brevity in your answer.  1.79. What is the ratio of the Vaccinated children(%) in Algeria in 1988 to that in 1991?
Your response must be concise. 0.95. What is the ratio of the Vaccinated children(%) of Mexico in 1988 to that in 1991?
Give a very brief answer. 0.79. What is the ratio of the Vaccinated children(%) in High income: OECD in 1989 to that in 1990?
Provide a short and direct response. 1.03. What is the ratio of the Vaccinated children(%) of Afghanistan in 1989 to that in 1990?
Make the answer very short. 1.1. What is the ratio of the Vaccinated children(%) of Mexico in 1989 to that in 1990?
Keep it short and to the point. 1.13. What is the ratio of the Vaccinated children(%) in High income: OECD in 1989 to that in 1991?
Make the answer very short. 1.04. What is the ratio of the Vaccinated children(%) of Afghanistan in 1989 to that in 1991?
Your answer should be compact. 1.16. What is the ratio of the Vaccinated children(%) of Algeria in 1989 to that in 1991?
Your answer should be very brief. 0.96. What is the ratio of the Vaccinated children(%) in Mexico in 1989 to that in 1991?
Make the answer very short. 0.96. What is the ratio of the Vaccinated children(%) in High income: OECD in 1990 to that in 1991?
Your response must be concise. 1.01. What is the ratio of the Vaccinated children(%) in Afghanistan in 1990 to that in 1991?
Provide a short and direct response. 1.05. What is the ratio of the Vaccinated children(%) of Algeria in 1990 to that in 1991?
Provide a succinct answer. 0.98. What is the ratio of the Vaccinated children(%) of Mexico in 1990 to that in 1991?
Keep it short and to the point. 0.84. What is the difference between the highest and the second highest Vaccinated children(%) in High income: OECD?
Offer a very short reply. 2.04. What is the difference between the highest and the second highest Vaccinated children(%) of Afghanistan?
Provide a succinct answer. 3. What is the difference between the highest and the second highest Vaccinated children(%) of Algeria?
Provide a succinct answer. 2. What is the difference between the highest and the lowest Vaccinated children(%) of High income: OECD?
Give a very brief answer. 8.54. What is the difference between the highest and the lowest Vaccinated children(%) in Afghanistan?
Keep it short and to the point. 20. What is the difference between the highest and the lowest Vaccinated children(%) in Mexico?
Ensure brevity in your answer.  35. 